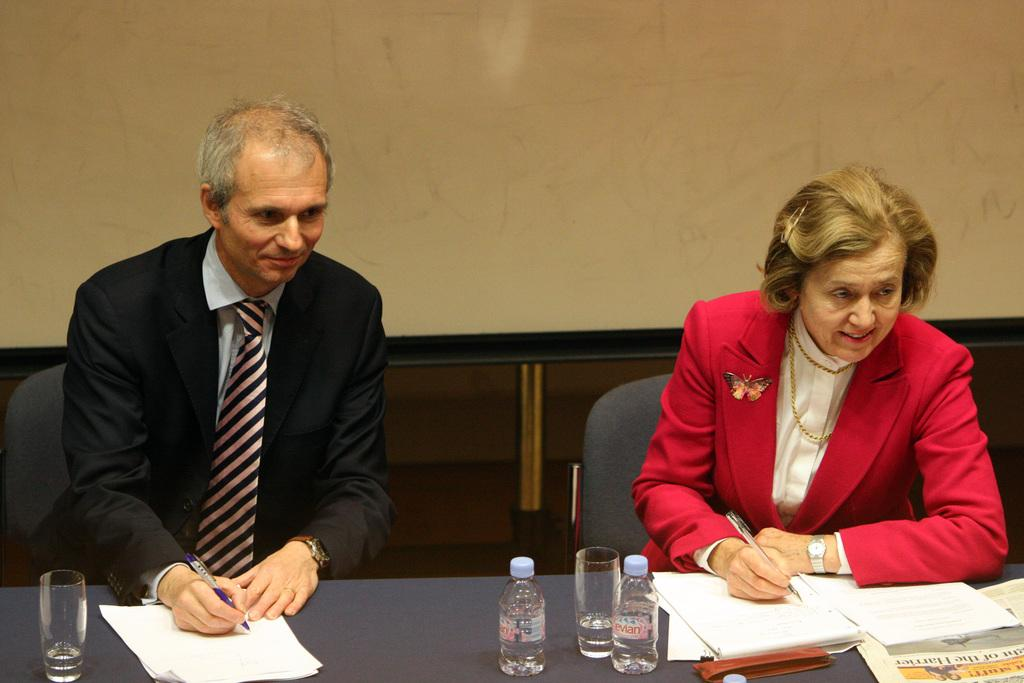How many people are in the image? There are two persons in the image. What are the persons doing in the image? The persons are sitting in chairs and writing on a paper. Where is the paper located? The paper is on a table. What other items can be seen on the table? There are two water bottles, glasses, and a newspaper on the table. What type of car is parked next to the table in the image? There is no car present in the image; it only shows two persons sitting and writing on a paper, along with items on a table. 